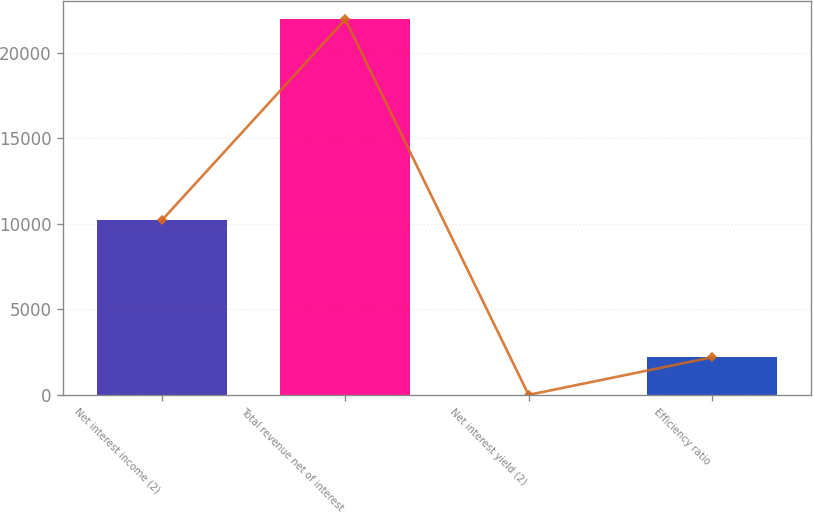<chart> <loc_0><loc_0><loc_500><loc_500><bar_chart><fcel>Net interest income (2)<fcel>Total revenue net of interest<fcel>Net interest yield (2)<fcel>Efficiency ratio<nl><fcel>10226<fcel>21960<fcel>2.22<fcel>2198<nl></chart> 